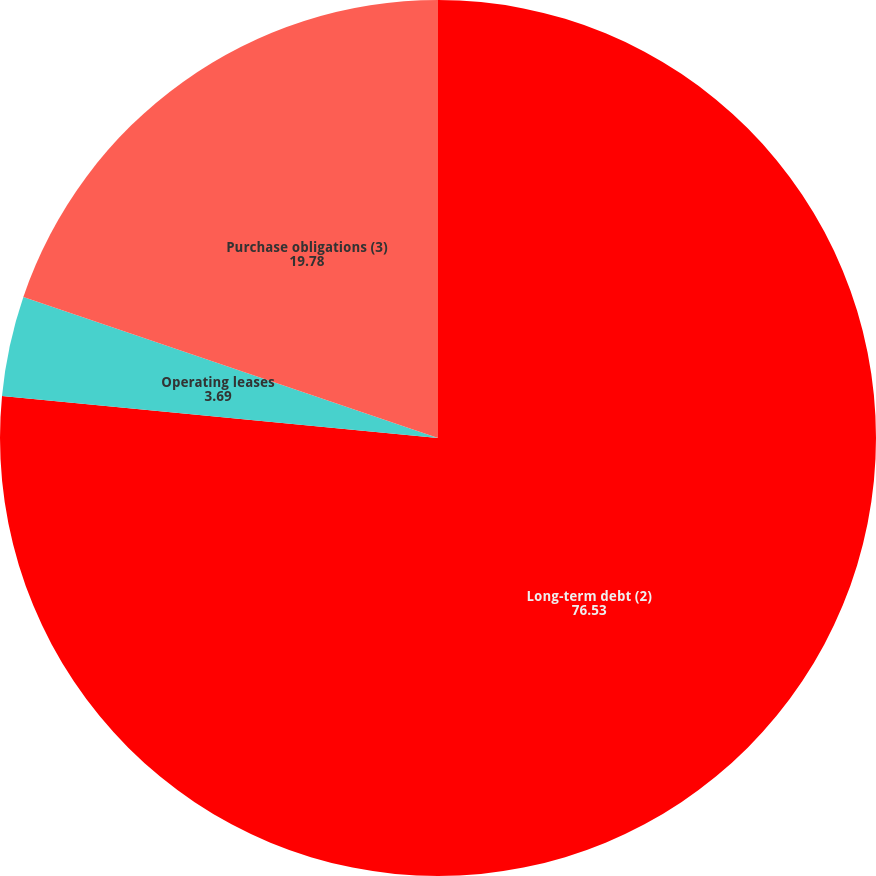Convert chart. <chart><loc_0><loc_0><loc_500><loc_500><pie_chart><fcel>Long-term debt (2)<fcel>Operating leases<fcel>Purchase obligations (3)<nl><fcel>76.53%<fcel>3.69%<fcel>19.78%<nl></chart> 